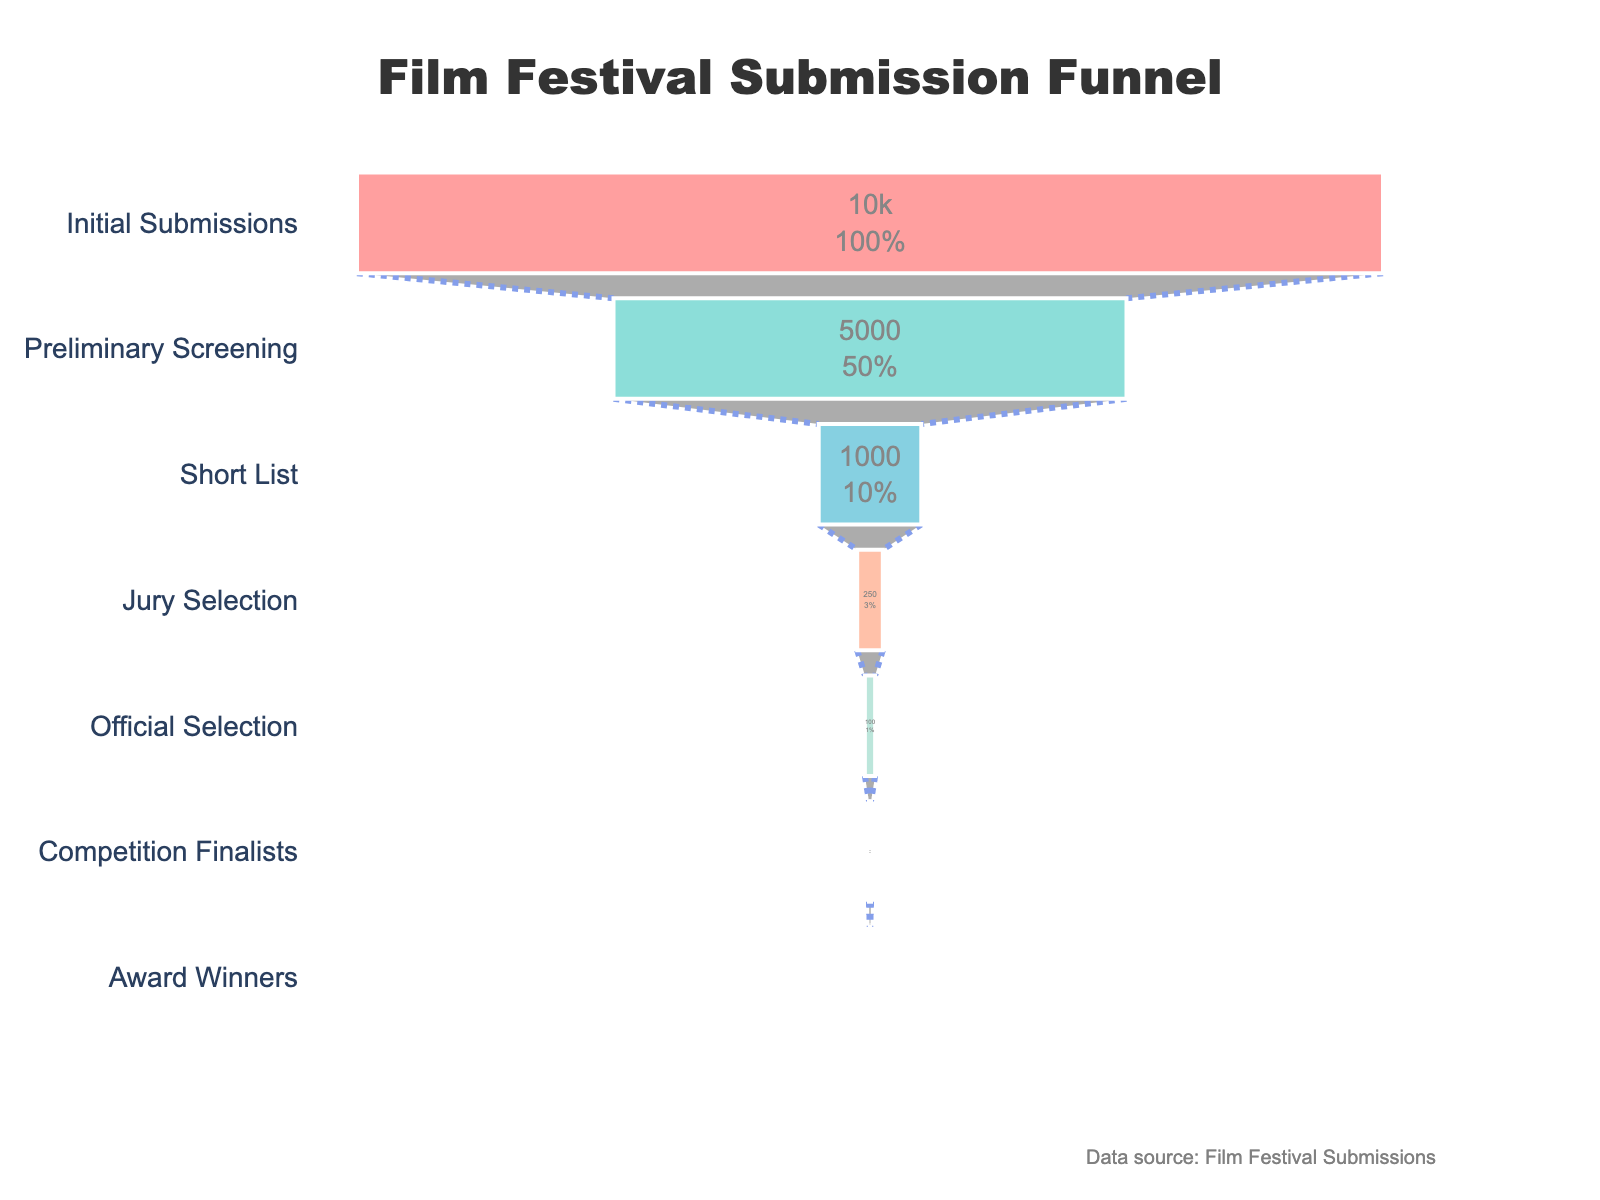What is the title of the funnel chart? The title is located at the top center of the figure and is easy to read.
Answer: Film Festival Submission Funnel How many stages are included in the funnel chart? By looking at the y-axis labels, we can count the different stages represented in the funnel chart.
Answer: 7 stages Which stage has the highest number of acceptances? By observing the length of the bars and noting the numbers inside them, we can identify the stage with the highest amount.
Answer: Initial Submissions What percentage of submissions reach the Short List stage? Divide the number of acceptances at the Short List stage by the total submissions and multiply by 100. (1000/10000) * 100 = 10%
Answer: 10% How many submissions are ultimately awarded? The final stage of the funnel chart shows this information.
Answer: 5 What’s the difference in the number of acceptances between Preliminary Screening and Jury Selection stages? Subtract the number of acceptances in Jury Selection from those in Preliminary Screening. 5000 - 250 = 4750
Answer: 4750 Which stage has the largest drop in the number of acceptances compared to the previous stage? Calculate the drop at each stage and identify the largest difference. (5000 - 1000), (1000 - 250), (250 - 100) … The largest drop is between Preliminary Screening and Short List, which is 5000 - 1000 = 4000
Answer: Preliminary Screening to Short List What is the average number of submissions across all stages shown? Sum the acceptances at all stages and divide by the number of stages. (10000 + 5000 + 1000 + 250 + 100 + 20 + 5) / 7 = 2335
Answer: 2335 How does the selection process change as we move through the stages? It’s clear from the decreasing size of the bars that more rigorous selection happens in the later stages, reducing the number of acceptances substantially.
Answer: More rigorous selection leads to fewer acceptances In percentage terms, which stage has the most significant reduction compared to the previous stage? Calculate the percentage reduction for each stage. The highest percentage reduction comes between Jury Selection and Official Selection. ((1000 - 250) / 1000) * 100 = 75%
Answer: Jury Selection to Official Selection 